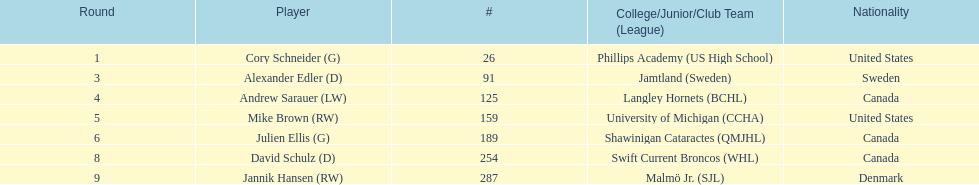List only the american players. Cory Schneider (G), Mike Brown (RW). 